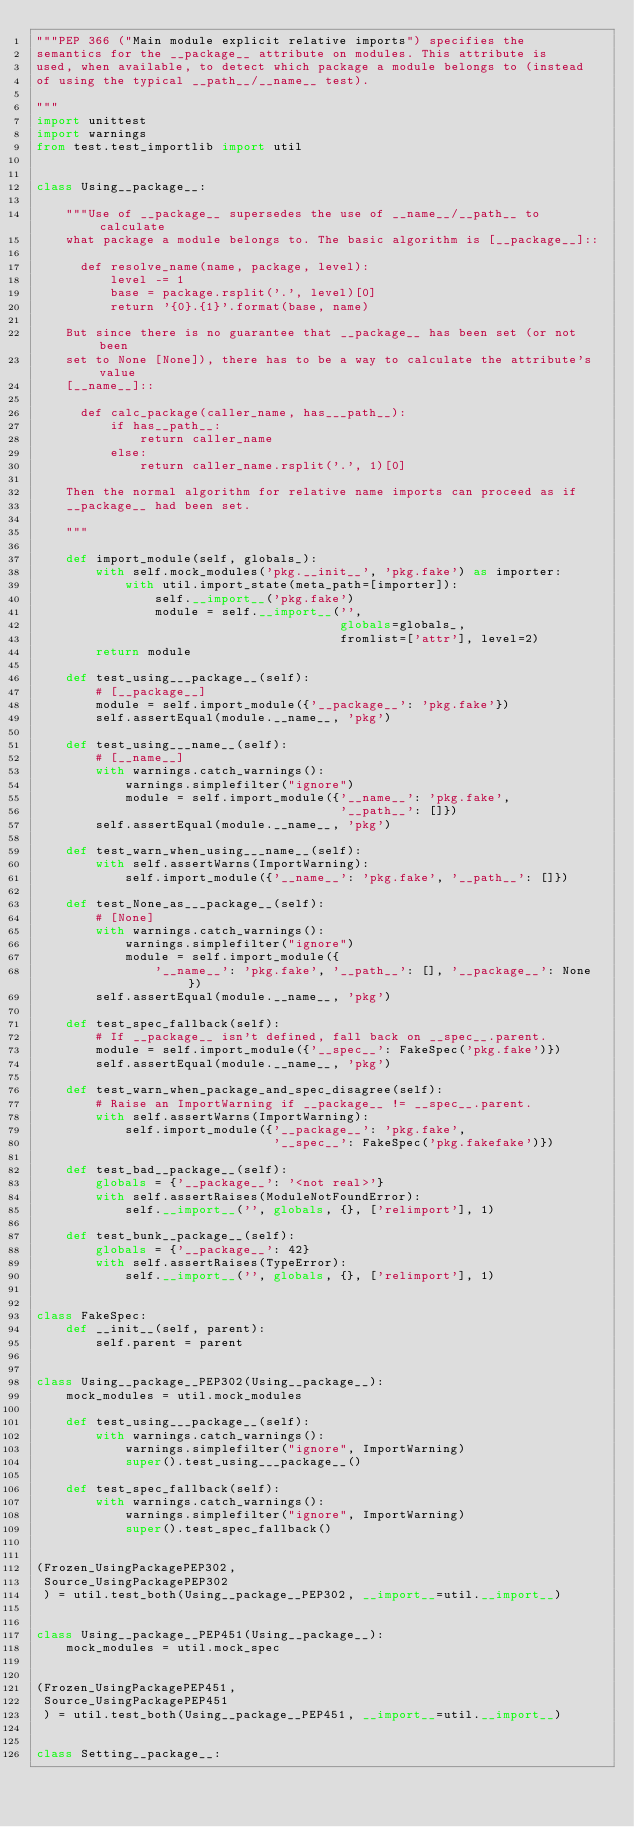<code> <loc_0><loc_0><loc_500><loc_500><_Python_>"""PEP 366 ("Main module explicit relative imports") specifies the
semantics for the __package__ attribute on modules. This attribute is
used, when available, to detect which package a module belongs to (instead
of using the typical __path__/__name__ test).

"""
import unittest
import warnings
from test.test_importlib import util


class Using__package__:

    """Use of __package__ supersedes the use of __name__/__path__ to calculate
    what package a module belongs to. The basic algorithm is [__package__]::

      def resolve_name(name, package, level):
          level -= 1
          base = package.rsplit('.', level)[0]
          return '{0}.{1}'.format(base, name)

    But since there is no guarantee that __package__ has been set (or not been
    set to None [None]), there has to be a way to calculate the attribute's value
    [__name__]::

      def calc_package(caller_name, has___path__):
          if has__path__:
              return caller_name
          else:
              return caller_name.rsplit('.', 1)[0]

    Then the normal algorithm for relative name imports can proceed as if
    __package__ had been set.

    """

    def import_module(self, globals_):
        with self.mock_modules('pkg.__init__', 'pkg.fake') as importer:
            with util.import_state(meta_path=[importer]):
                self.__import__('pkg.fake')
                module = self.__import__('',
                                         globals=globals_,
                                         fromlist=['attr'], level=2)
        return module

    def test_using___package__(self):
        # [__package__]
        module = self.import_module({'__package__': 'pkg.fake'})
        self.assertEqual(module.__name__, 'pkg')

    def test_using___name__(self):
        # [__name__]
        with warnings.catch_warnings():
            warnings.simplefilter("ignore")
            module = self.import_module({'__name__': 'pkg.fake',
                                         '__path__': []})
        self.assertEqual(module.__name__, 'pkg')

    def test_warn_when_using___name__(self):
        with self.assertWarns(ImportWarning):
            self.import_module({'__name__': 'pkg.fake', '__path__': []})

    def test_None_as___package__(self):
        # [None]
        with warnings.catch_warnings():
            warnings.simplefilter("ignore")
            module = self.import_module({
                '__name__': 'pkg.fake', '__path__': [], '__package__': None })
        self.assertEqual(module.__name__, 'pkg')

    def test_spec_fallback(self):
        # If __package__ isn't defined, fall back on __spec__.parent.
        module = self.import_module({'__spec__': FakeSpec('pkg.fake')})
        self.assertEqual(module.__name__, 'pkg')

    def test_warn_when_package_and_spec_disagree(self):
        # Raise an ImportWarning if __package__ != __spec__.parent.
        with self.assertWarns(ImportWarning):
            self.import_module({'__package__': 'pkg.fake',
                                '__spec__': FakeSpec('pkg.fakefake')})

    def test_bad__package__(self):
        globals = {'__package__': '<not real>'}
        with self.assertRaises(ModuleNotFoundError):
            self.__import__('', globals, {}, ['relimport'], 1)

    def test_bunk__package__(self):
        globals = {'__package__': 42}
        with self.assertRaises(TypeError):
            self.__import__('', globals, {}, ['relimport'], 1)


class FakeSpec:
    def __init__(self, parent):
        self.parent = parent


class Using__package__PEP302(Using__package__):
    mock_modules = util.mock_modules

    def test_using___package__(self):
        with warnings.catch_warnings():
            warnings.simplefilter("ignore", ImportWarning)
            super().test_using___package__()

    def test_spec_fallback(self):
        with warnings.catch_warnings():
            warnings.simplefilter("ignore", ImportWarning)
            super().test_spec_fallback()


(Frozen_UsingPackagePEP302,
 Source_UsingPackagePEP302
 ) = util.test_both(Using__package__PEP302, __import__=util.__import__)


class Using__package__PEP451(Using__package__):
    mock_modules = util.mock_spec


(Frozen_UsingPackagePEP451,
 Source_UsingPackagePEP451
 ) = util.test_both(Using__package__PEP451, __import__=util.__import__)


class Setting__package__:
</code> 